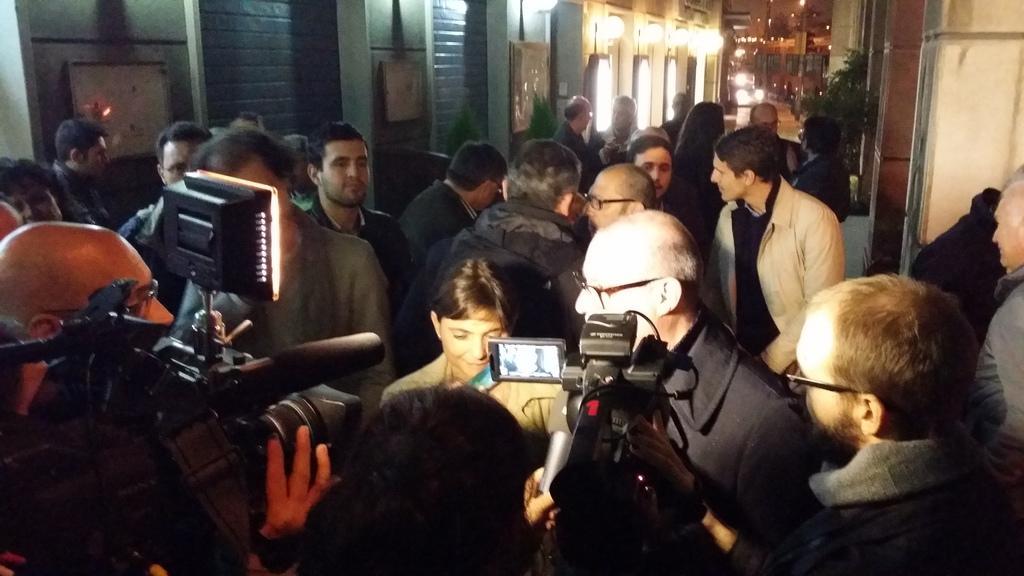Describe this image in one or two sentences. This picture describes about group of people, few people holding cameras, in the background we can see few lights and plants. 